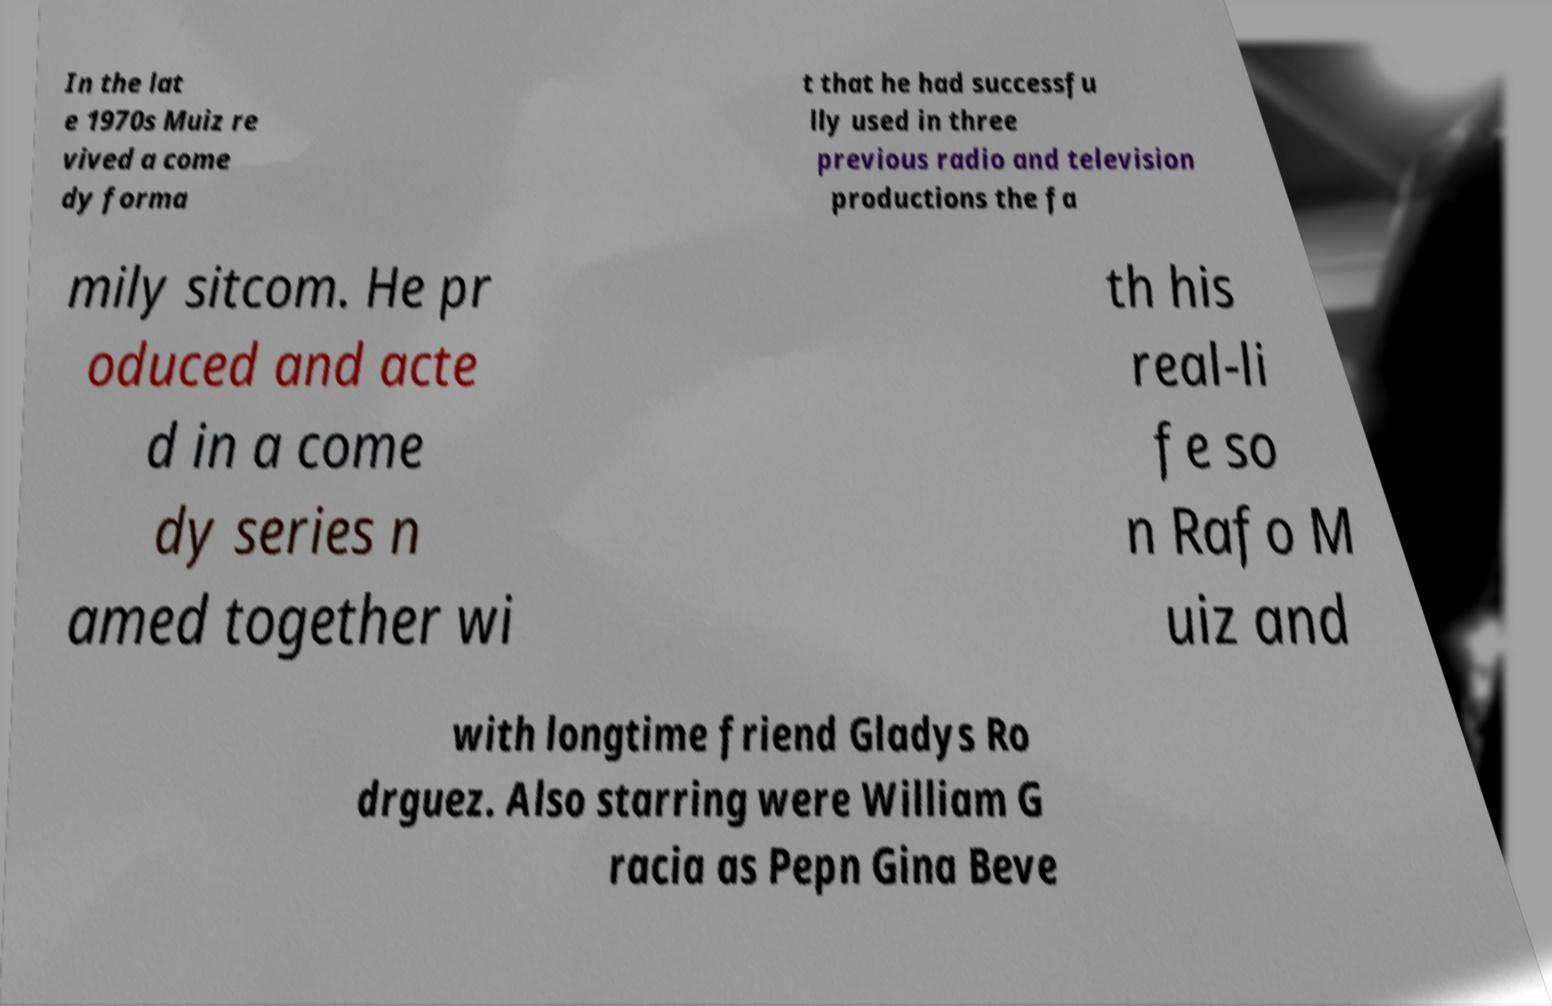Please identify and transcribe the text found in this image. In the lat e 1970s Muiz re vived a come dy forma t that he had successfu lly used in three previous radio and television productions the fa mily sitcom. He pr oduced and acte d in a come dy series n amed together wi th his real-li fe so n Rafo M uiz and with longtime friend Gladys Ro drguez. Also starring were William G racia as Pepn Gina Beve 